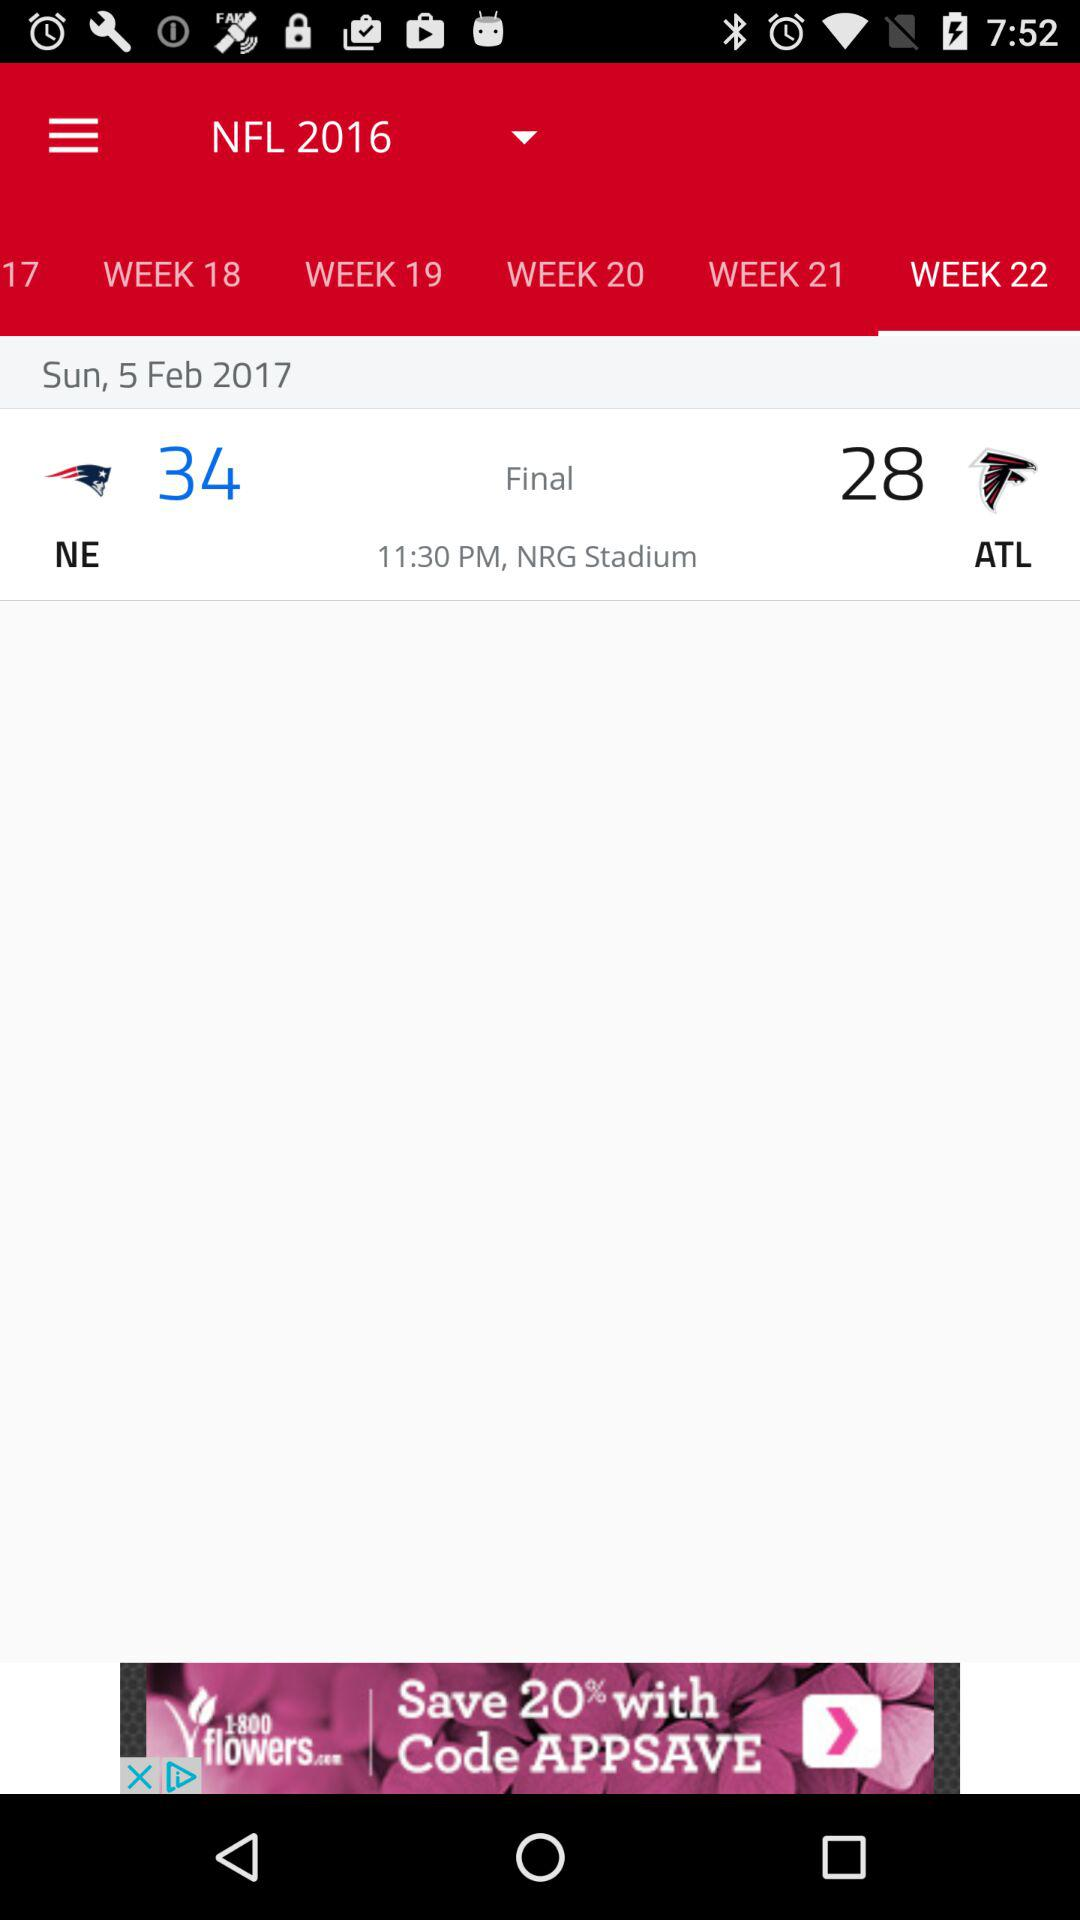What is the name of the stadium? The name of the stadium is "NRG Stadium". 